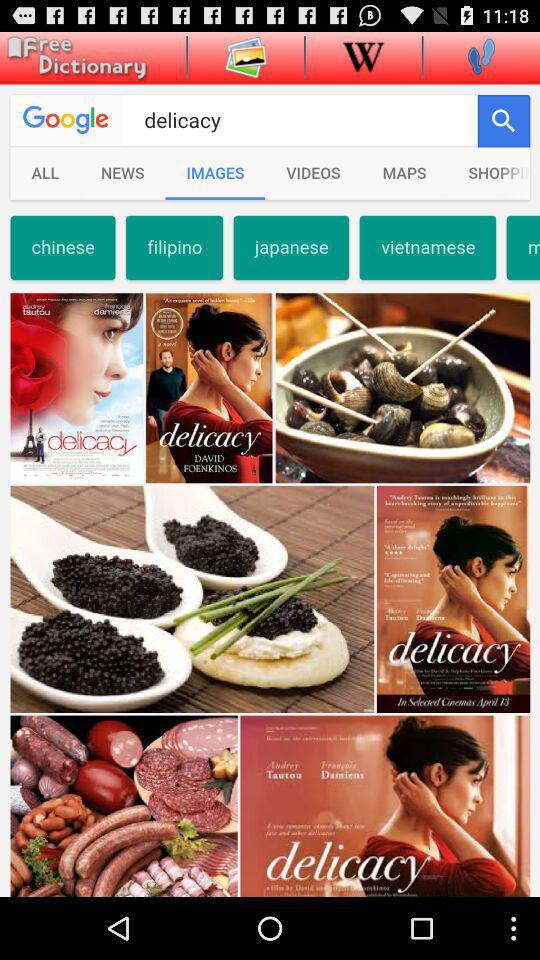What input text is entered into the search bar? The entered input text is "delicacy". 